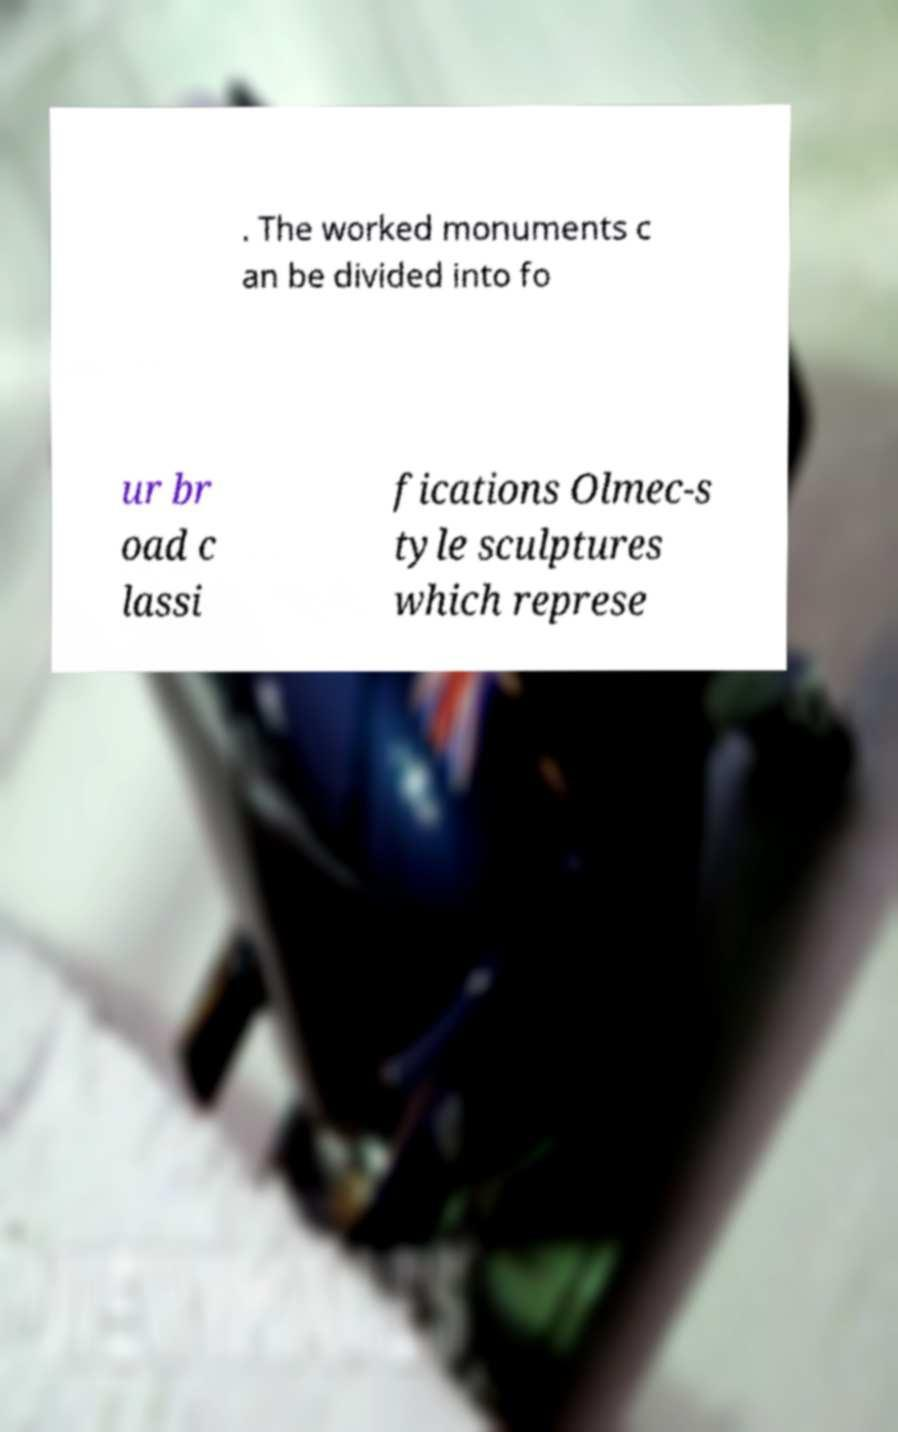Please read and relay the text visible in this image. What does it say? . The worked monuments c an be divided into fo ur br oad c lassi fications Olmec-s tyle sculptures which represe 